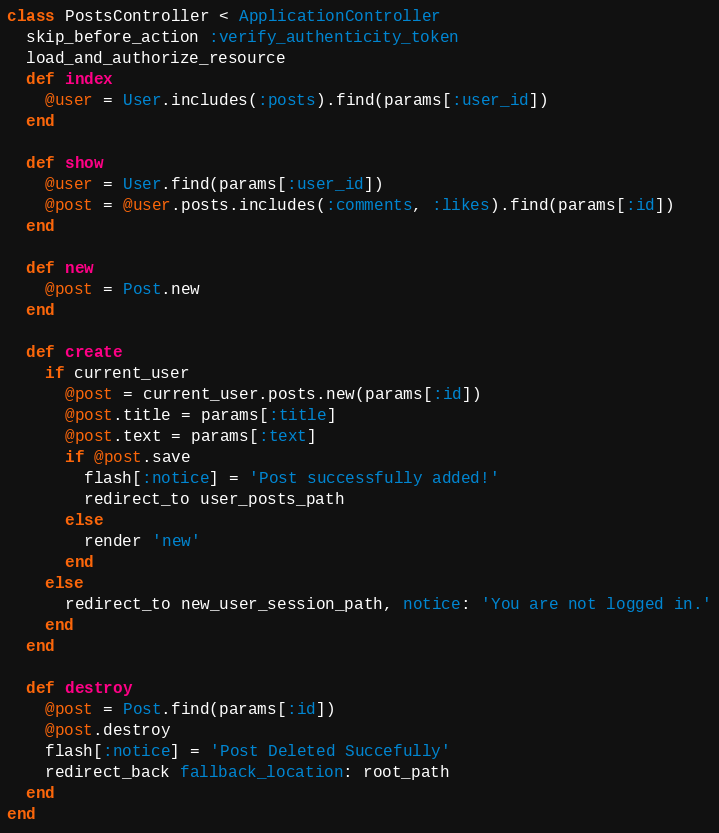<code> <loc_0><loc_0><loc_500><loc_500><_Ruby_>class PostsController < ApplicationController
  skip_before_action :verify_authenticity_token
  load_and_authorize_resource
  def index
    @user = User.includes(:posts).find(params[:user_id])
  end

  def show
    @user = User.find(params[:user_id])
    @post = @user.posts.includes(:comments, :likes).find(params[:id])
  end

  def new
    @post = Post.new
  end

  def create
    if current_user
      @post = current_user.posts.new(params[:id])
      @post.title = params[:title]
      @post.text = params[:text]
      if @post.save
        flash[:notice] = 'Post successfully added!'
        redirect_to user_posts_path
      else
        render 'new'
      end
    else
      redirect_to new_user_session_path, notice: 'You are not logged in.'
    end
  end

  def destroy
    @post = Post.find(params[:id])
    @post.destroy
    flash[:notice] = 'Post Deleted Succefully'
    redirect_back fallback_location: root_path
  end
end
</code> 